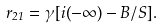<formula> <loc_0><loc_0><loc_500><loc_500>r _ { 2 1 } = \gamma [ i ( - \infty ) - B / S ] .</formula> 